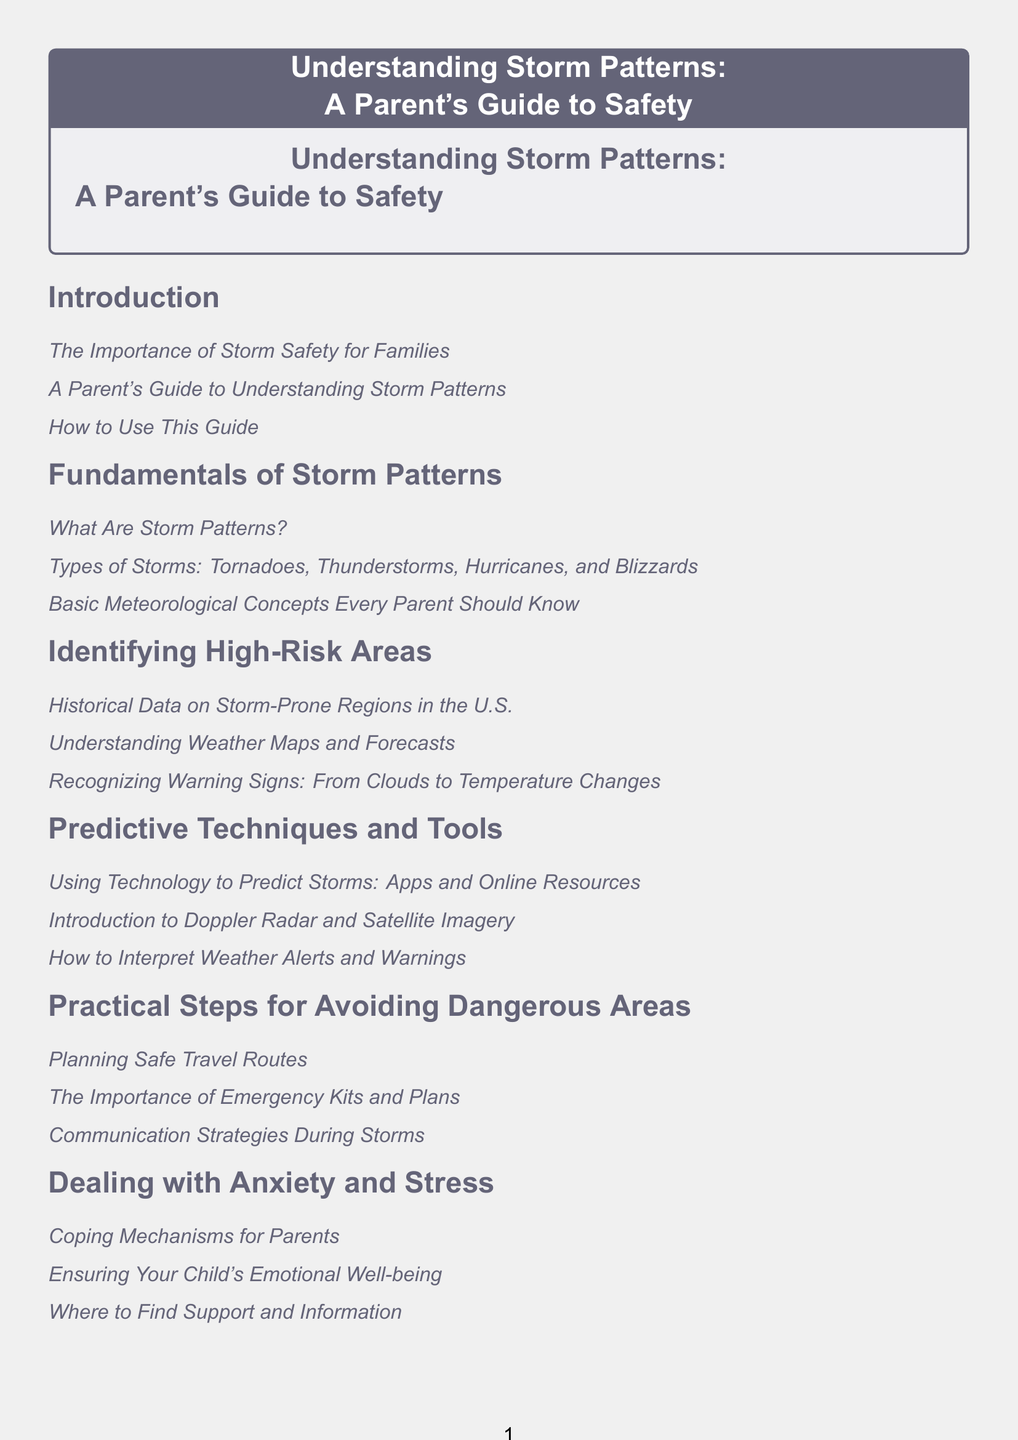What is the first section title in the document? The first section is titled "Introduction."
Answer: Introduction What kind of storms are discussed in the document? The document mentions tornadoes, thunderstorms, hurricanes, and blizzards as types of storms.
Answer: Tornadoes, thunderstorms, hurricanes, and blizzards What is one tool mentioned for predicting storms? The document lists apps as one of the predictive tools for storms.
Answer: Apps How many subsections are in the section "Dealing with Anxiety and Stress"? The section contains three subsections, focusing on coping mechanisms, emotional well-being, and support.
Answer: Three What is emphasized in the "Practical Steps for Avoiding Dangerous Areas" section? The section emphasizes planning safe travel routes and the importance of emergency kits.
Answer: Planning safe travel routes and emergency kits How should parents cope with storm-related anxiety according to the document? The document provides mechanisms for parents to cope with anxiety, suggesting various strategies.
Answer: Coping mechanisms What is the last subsection in the document? The last subsection is "Final Words of Encouragement."
Answer: Final Words of Encouragement Which section contains real-life examples? The section titled "Case Studies and Real-life Examples" provides such examples.
Answer: Case Studies and Real-life Examples What is the main focus of the section titled "Identifying High-Risk Areas"? This section focuses on understanding historical data, weather maps, and warning signs.
Answer: Understanding historical data, weather maps, and warning signs 